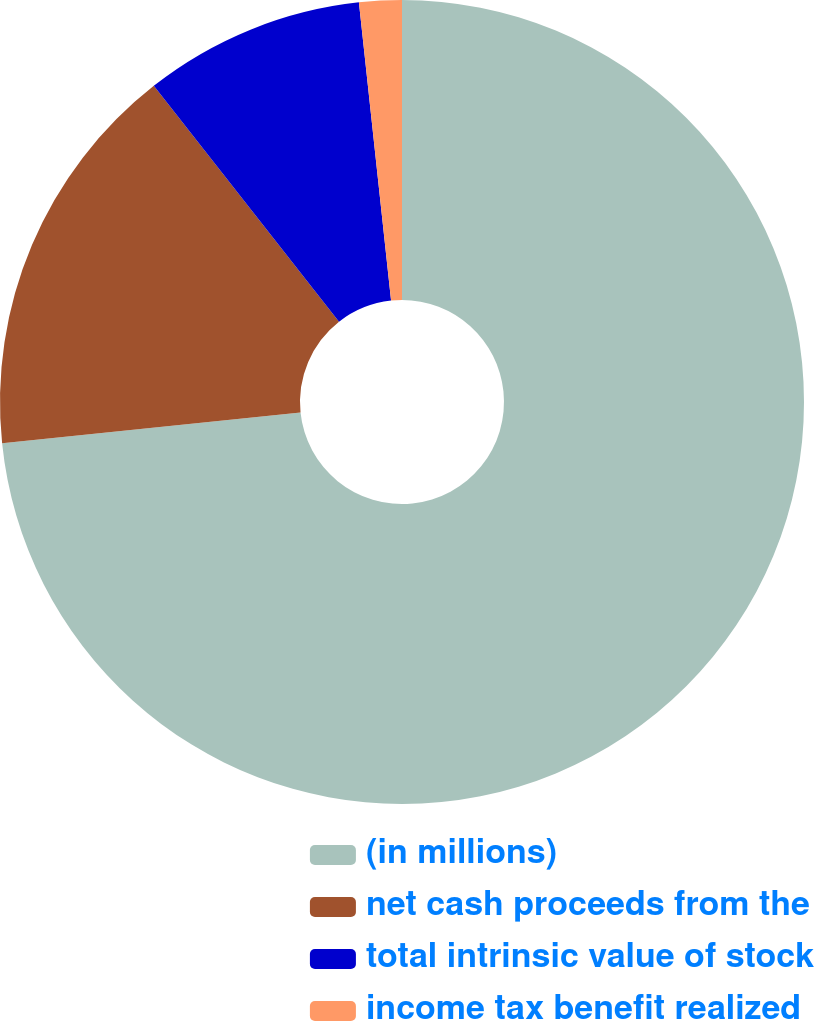<chart> <loc_0><loc_0><loc_500><loc_500><pie_chart><fcel>(in millions)<fcel>net cash proceeds from the<fcel>total intrinsic value of stock<fcel>income tax benefit realized<nl><fcel>73.36%<fcel>16.04%<fcel>8.88%<fcel>1.71%<nl></chart> 